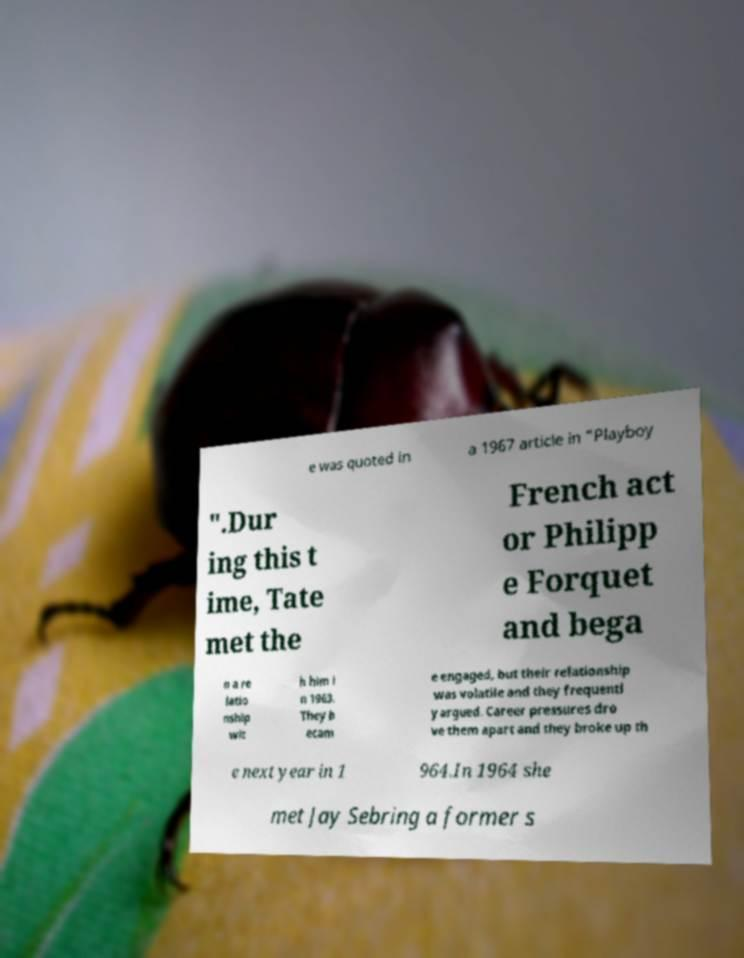What messages or text are displayed in this image? I need them in a readable, typed format. e was quoted in a 1967 article in "Playboy ".Dur ing this t ime, Tate met the French act or Philipp e Forquet and bega n a re latio nship wit h him i n 1963. They b ecam e engaged, but their relationship was volatile and they frequentl y argued. Career pressures dro ve them apart and they broke up th e next year in 1 964.In 1964 she met Jay Sebring a former s 